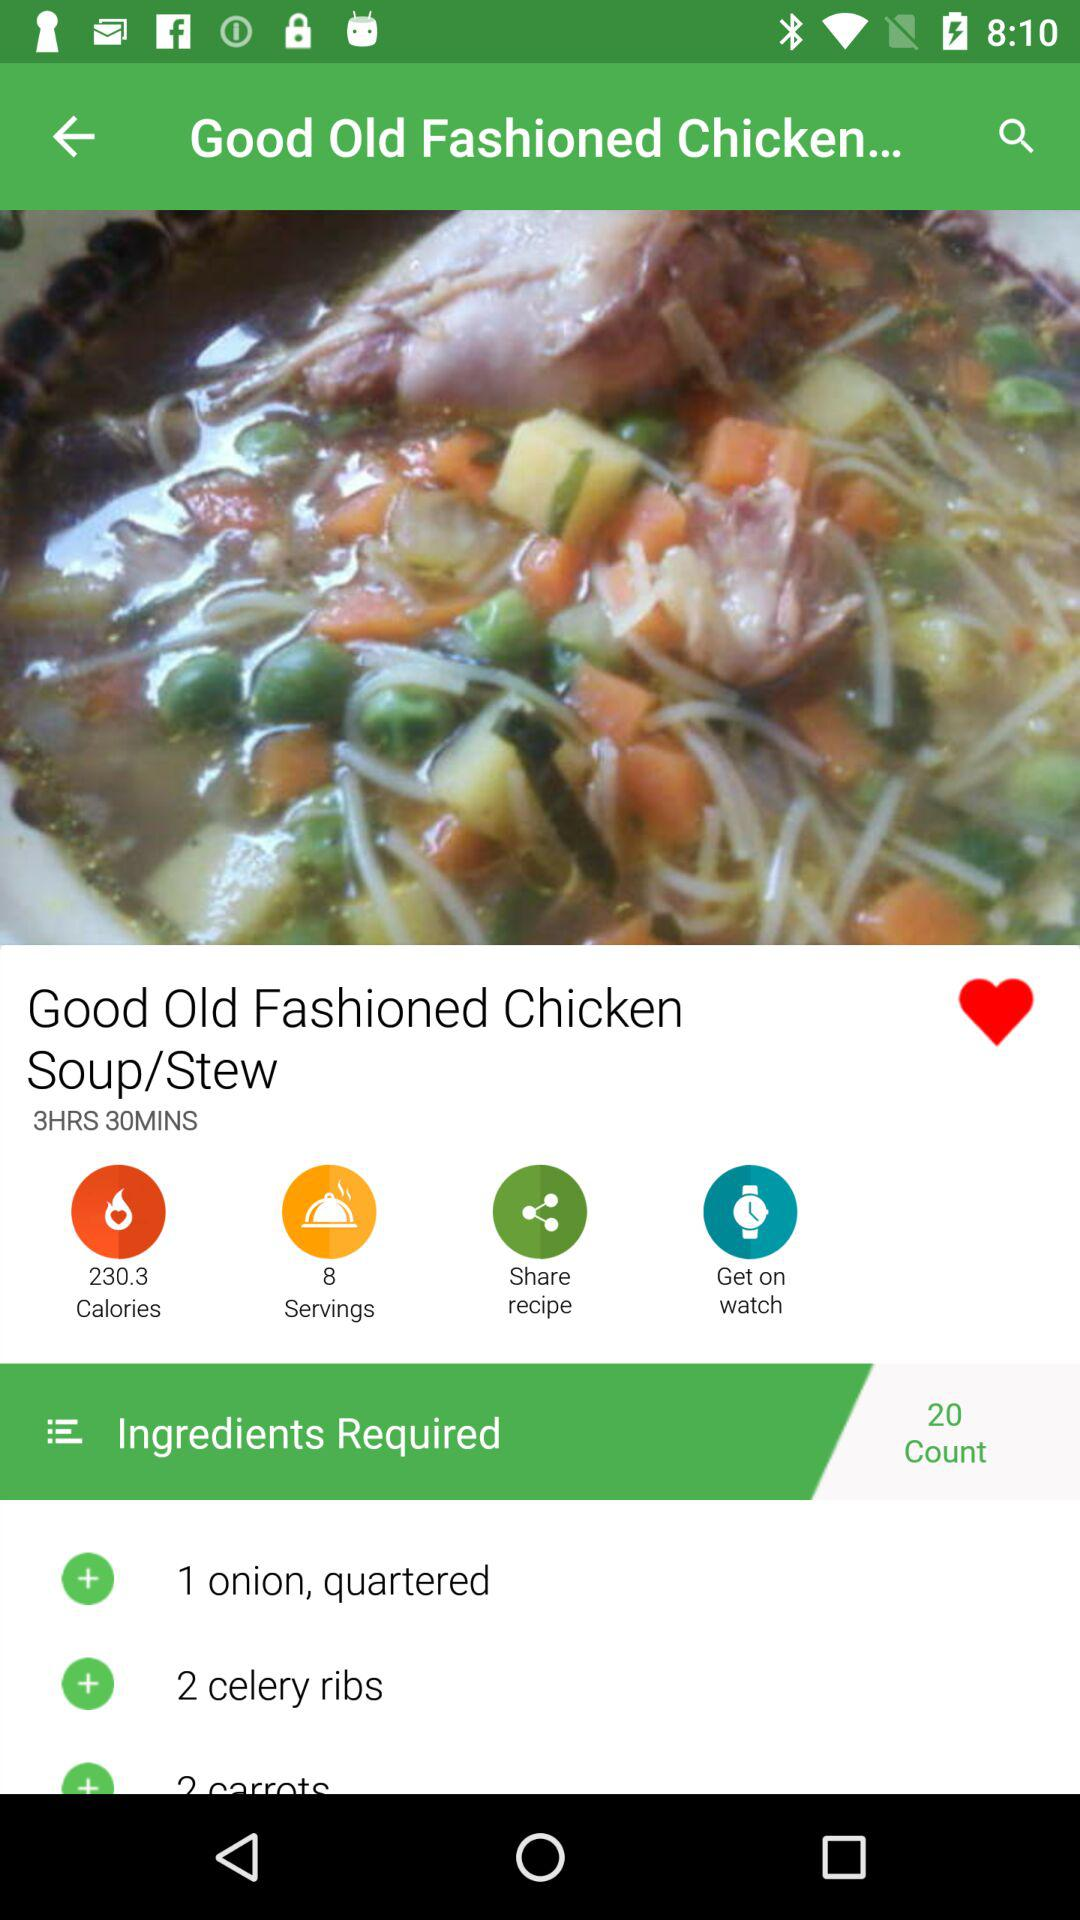What is the number of servings of the dish? The number of servings is 8. 